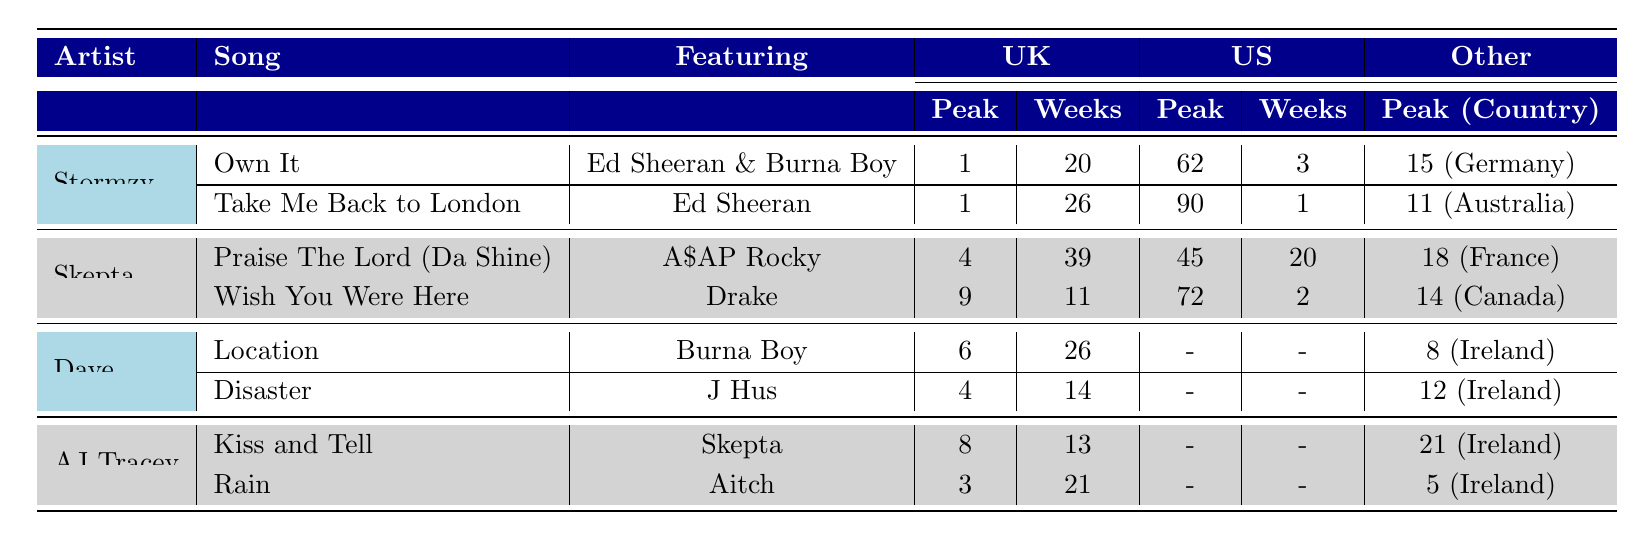What song by Stormzy peaked at 1 in the UK? The table shows that the songs "Own It" and "Take Me Back to London" by Stormzy both peaked at position 1 in the UK.
Answer: Own It, Take Me Back to London Which artist collaborated with AJ Tracey on the song "Kiss and Tell"? According to the table, AJ Tracey collaborated with Skepta on the song "Kiss and Tell".
Answer: Skepta How many weeks did "Disaster" by Dave spend on the UK charts? The table indicates that "Disaster" spent 14 weeks on the UK charts.
Answer: 14 Which song featuring Burna Boy by Dave reached a peak position of 6? The table lists "Location" as the song featuring Burna Boy by Dave that peaked at position 6.
Answer: Location What is the peak position of "Praise The Lord (Da Shine)" in the US? The table shows that "Praise The Lord (Da Shine)" peaked at position 45 in the US.
Answer: 45 Which song by Skepta has a higher peak position in the UK, "Praise The Lord (Da Shine)" or "Wish You Were Here"? The table reveals that "Praise The Lord (Da Shine)" peaked at 4 in the UK, while "Wish You Were Here" peaked at 9. Thus, "Praise The Lord (Da Shine)" has a higher peak position.
Answer: Praise The Lord (Da Shine) What is the total number of weeks "Take Me Back to London" spent on the UK charts? The table indicates that "Take Me Back to London" spent 26 weeks on the UK charts.
Answer: 26 Did any of Dave's collaborations peak at number 4 in the UK? Yes, looking at the table, "Disaster" peaked at 4 in the UK.
Answer: Yes Which artist had the longest chart presence in the UK and how many weeks? Comparing the weeks on the UK charts, Stormzy's "Take Me Back to London" had the longest chart presence with 26 weeks, while Skepta's "Praise The Lord (Da Shine)" had 39 weeks in UK but under a different artist name; collectively, Skepta had more weeks.
Answer: Skepta, 39 weeks How many weeks did "Location" spend in total across the UK, Ireland, and the Netherlands? The table shows "Location" spent 26 weeks in the UK, 18 weeks in Ireland, and 3 weeks in the Netherlands. Summing those gives a total of 26 + 18 + 3 = 47 weeks.
Answer: 47 weeks 